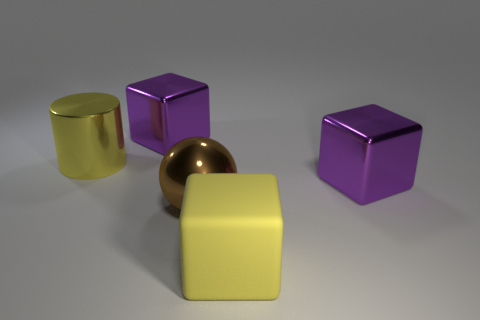How does the surface texture of the yellow rubber cube compare to that of the purple cubes? The yellow rubber cube has a more matte and less reflective surface compared to the purple cubes, which have a highly glossy finish that reflects the light sharply. 